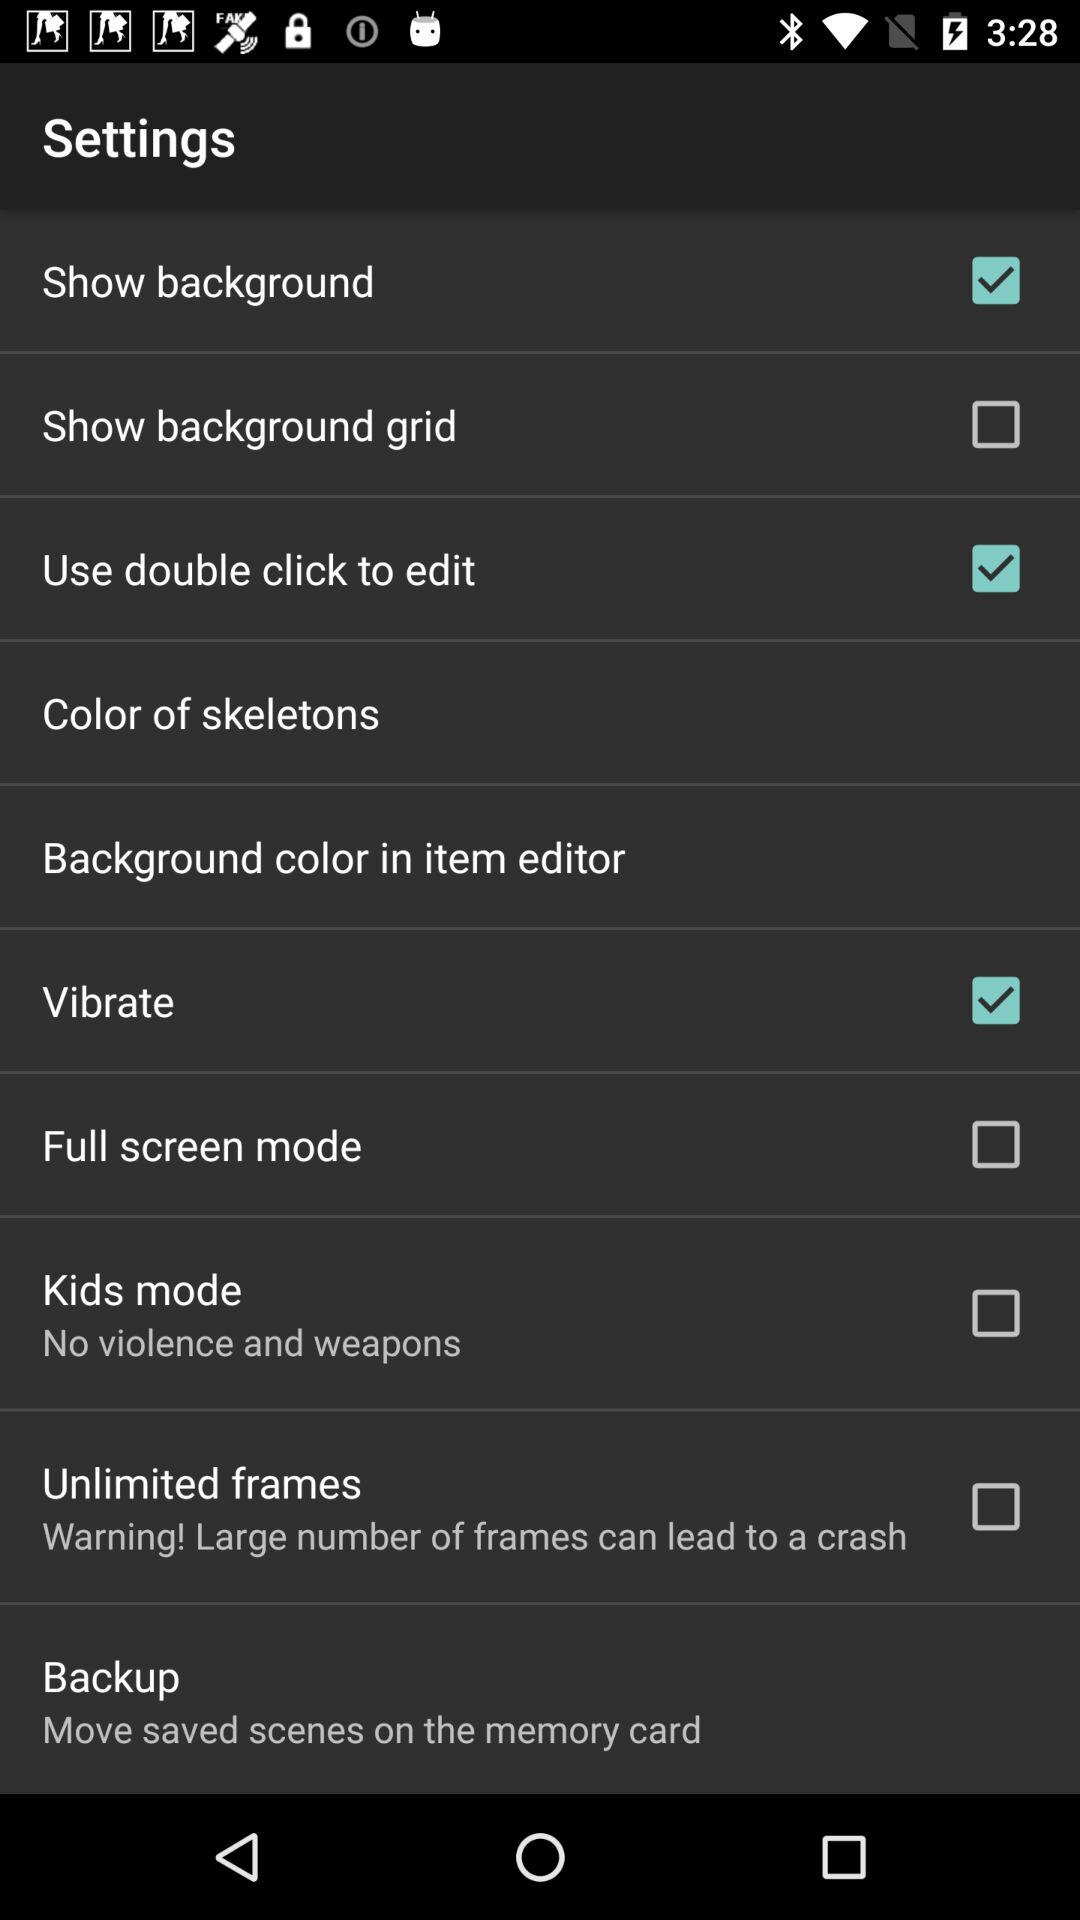What's the status of the show background? The status is on. 